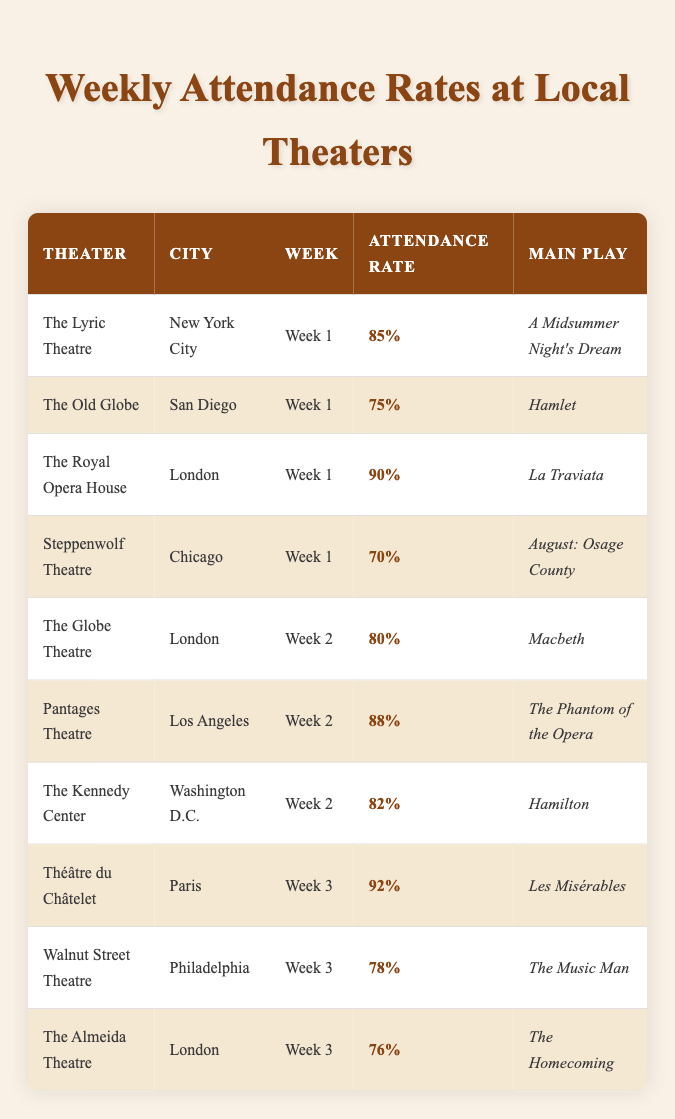What is the highest attendance rate recorded during Week 1? In Week 1, the attendance rates for the theaters are as follows: The Lyric Theatre (85%), The Old Globe (75%), The Royal Opera House (90%), and Steppenwolf Theatre (70%). The highest attendance rate is 90%, recorded at The Royal Opera House.
Answer: 90% Which theater had the lowest attendance rate in Week 2? The attendance rates for Week 2 are: The Globe Theatre (80%), Pantages Theatre (88%), and The Kennedy Center (82%). Comparing these rates, The Globe Theatre has the lowest attendance rate at 80%.
Answer: The Globe Theatre Is the attendance rate for Les Misérables higher than for The Music Man? The attendance rate for Les Misérables at Théâtre du Châtelet in Week 3 is 92%, while The Music Man at Walnut Street Theatre has an attendance rate of 78%. Thus, 92% is greater than 78%.
Answer: Yes What is the average attendance rate across all theaters in Week 3? In Week 3, the attendance rates are Les Misérables (92%), The Music Man (78%), and The Homecoming (76%). To find the average, we add these rates: 92 + 78 + 76 = 246. Then, dividing by 3 (the number of theaters) gives an average of 246 / 3 = 82.
Answer: 82 Which city had the highest attendance rate in Week 1? The attendance rates for Week 1 in various cities are as follows: New York City (85%), San Diego (75%), London (90%), and Chicago (70%). The highest attendance rate of 90% is in London at The Royal Opera House.
Answer: London How many theaters had an attendance rate of 80% or higher in Week 2? In Week 2, the attendance rates are: The Globe Theatre (80%), Pantages Theatre (88%), and The Kennedy Center (82%). Here, two theaters, Pantages Theatre and The Kennedy Center, have attendance rates above 80%, while The Globe Theatre matches that rate. Therefore, a total of three theaters meet the criteria.
Answer: 3 Is there any theater in London that had an attendance rate less than 80%? The Almeida Theatre in London had a reported attendance rate of 76%. This is less than 80%, confirming that at least one theater in London falls below that rate.
Answer: Yes What is the difference in attendance rates between the highest and lowest-rated shows in Week 1? In Week 1, the highest attendance rate is from The Royal Opera House at 90%, and the lowest is from Steppenwolf Theatre at 70%. The difference is calculated as 90 - 70 = 20.
Answer: 20 What play was performed at the theater with the lowest attendance rate in Week 3? The theaters and their attendance rates in Week 3 are: Théâtre du Châtelet (92% for Les Misérables), Walnut Street Theatre (78% for The Music Man), and The Almeida Theatre (76% for The Homecoming). The lowest attendance rate is 76% at The Almeida Theatre, which featured The Homecoming.
Answer: The Homecoming 